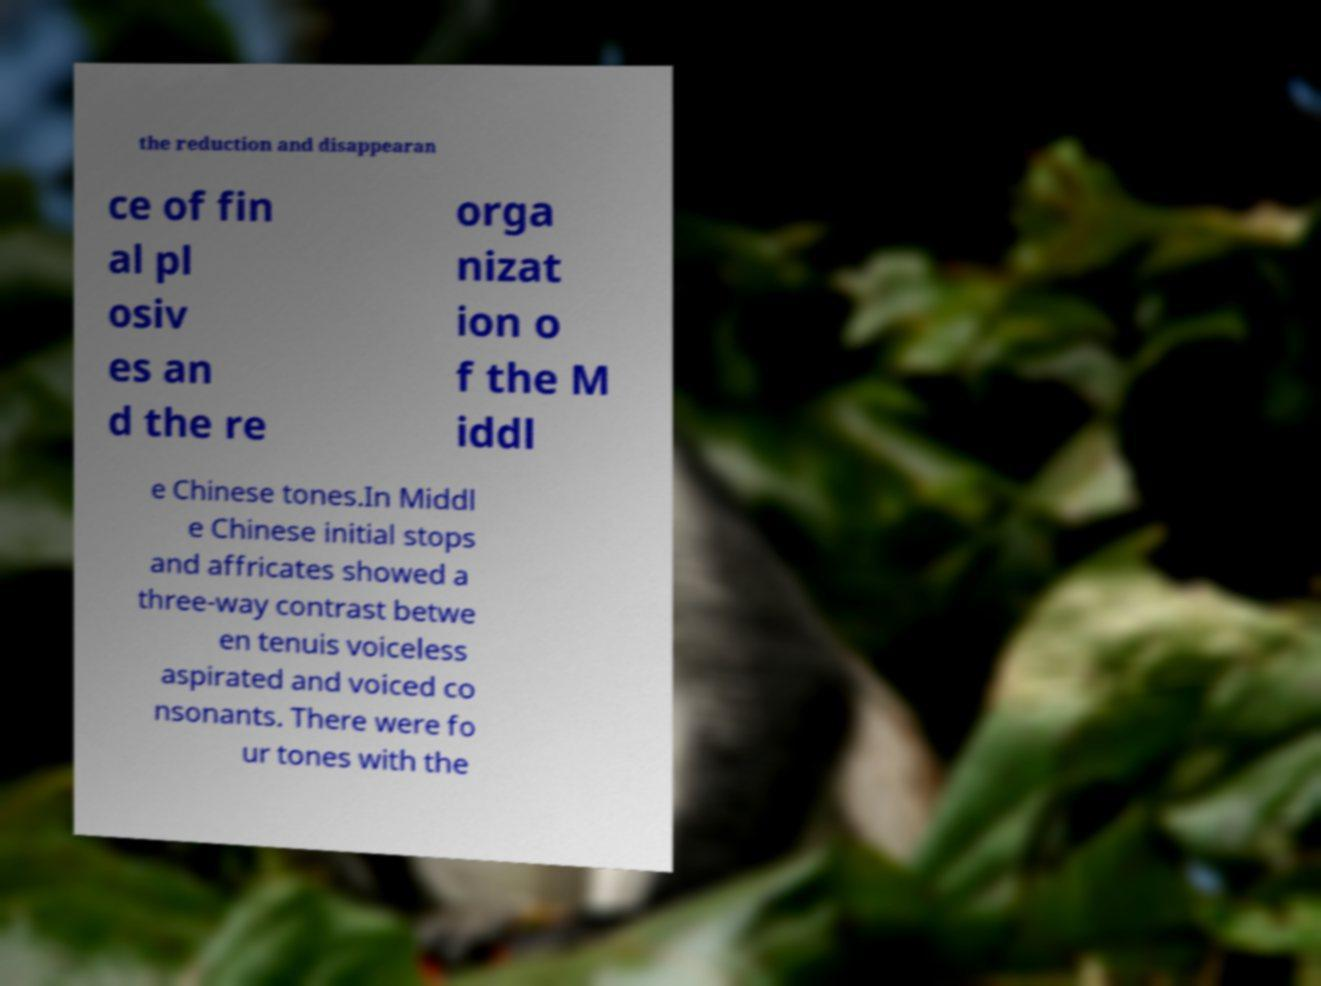Could you extract and type out the text from this image? the reduction and disappearan ce of fin al pl osiv es an d the re orga nizat ion o f the M iddl e Chinese tones.In Middl e Chinese initial stops and affricates showed a three-way contrast betwe en tenuis voiceless aspirated and voiced co nsonants. There were fo ur tones with the 